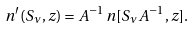Convert formula to latex. <formula><loc_0><loc_0><loc_500><loc_500>n ^ { \prime } ( S _ { \nu } , z ) = A ^ { - 1 } \, n [ S _ { \nu } A ^ { - 1 } , z ] .</formula> 